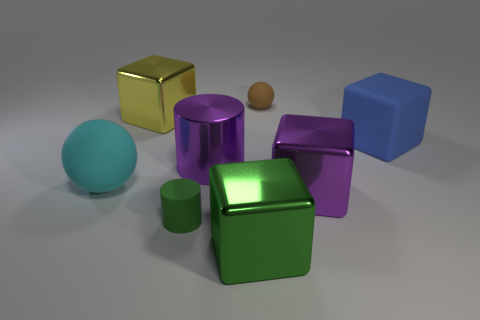What relationship do these objects convey? The objects, with their varying sizes, colors, and shapes, might represent diversity and the concept of uniqueness. They seem to be arranged with no specific pattern, perhaps suggesting a theme of randomness or the idea of objects in a shared space without a direct relationship. 